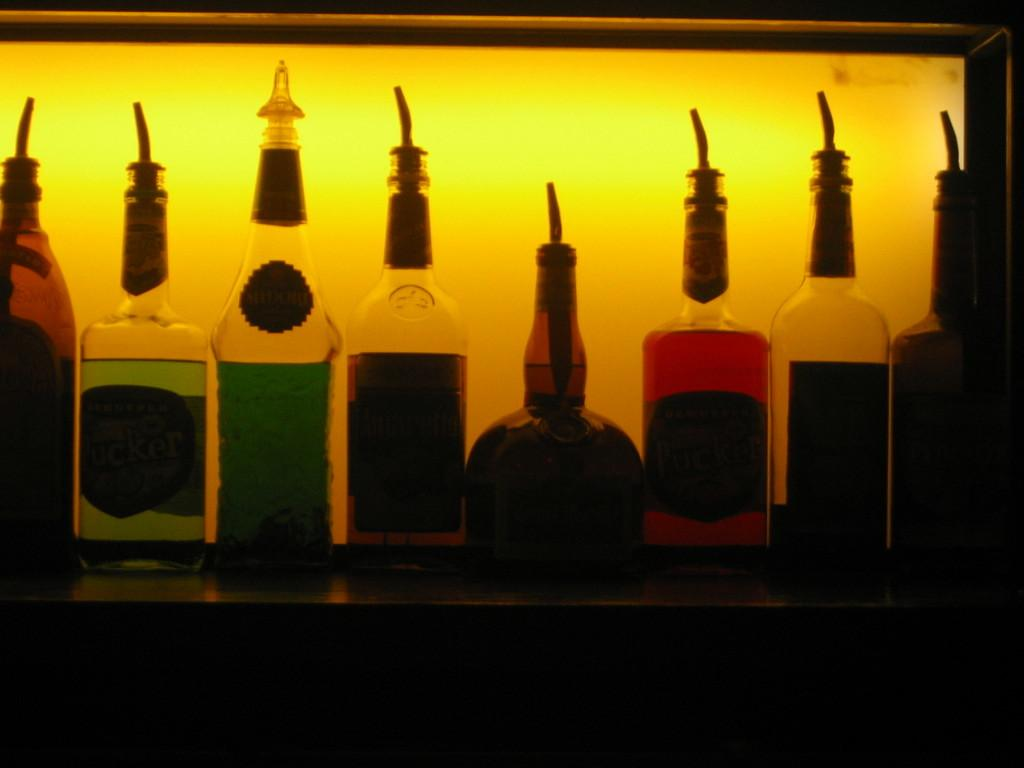What objects are present in the image? There are bottles in the image. What type of cake is being served at the event in the image? There is no cake or event present in the image; it only features bottles. How does the image make you feel? The image itself does not evoke feelings, as it is a static representation of bottles. 